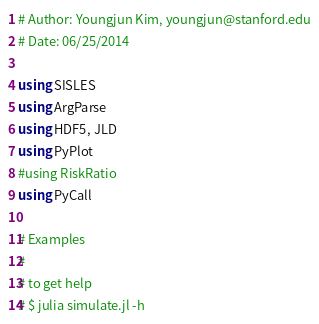Convert code to text. <code><loc_0><loc_0><loc_500><loc_500><_Julia_># Author: Youngjun Kim, youngjun@stanford.edu
# Date: 06/25/2014

using SISLES
using ArgParse
using HDF5, JLD
using PyPlot
#using RiskRatio
using PyCall

# Examples
#
# to get help
# $ julia simulate.jl -h</code> 